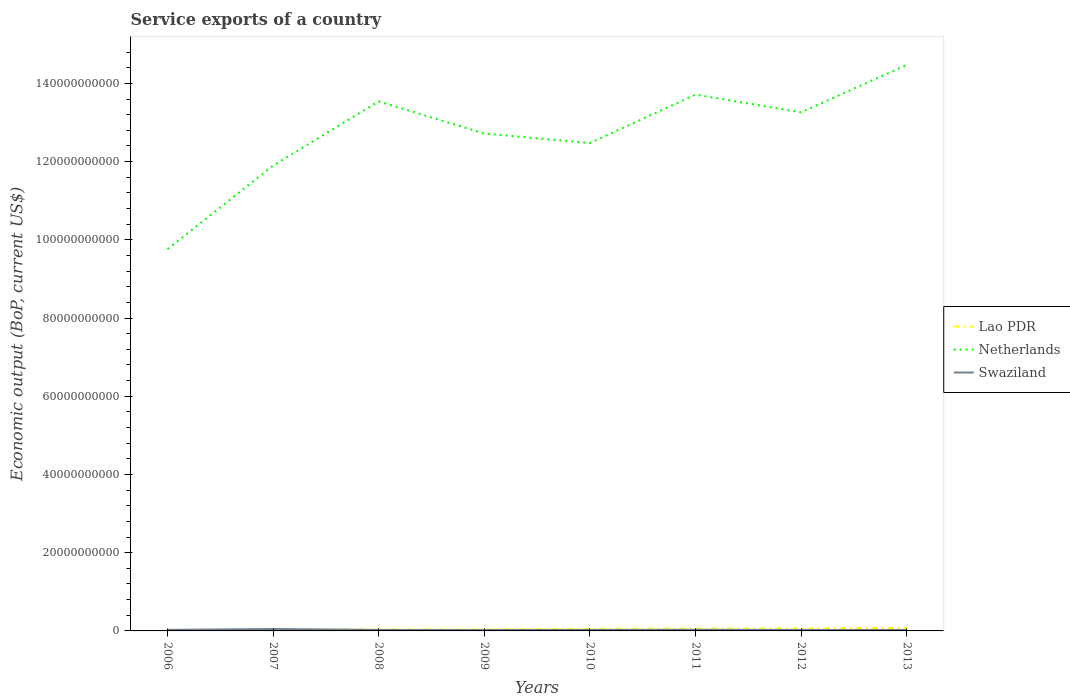How many different coloured lines are there?
Provide a succinct answer. 3. Does the line corresponding to Lao PDR intersect with the line corresponding to Swaziland?
Offer a terse response. Yes. Is the number of lines equal to the number of legend labels?
Offer a very short reply. Yes. Across all years, what is the maximum service exports in Netherlands?
Your answer should be compact. 9.76e+1. What is the total service exports in Lao PDR in the graph?
Provide a succinct answer. -1.80e+08. What is the difference between the highest and the second highest service exports in Swaziland?
Offer a very short reply. 2.83e+08. What is the difference between the highest and the lowest service exports in Netherlands?
Ensure brevity in your answer.  4. What is the difference between two consecutive major ticks on the Y-axis?
Provide a short and direct response. 2.00e+1. Does the graph contain any zero values?
Make the answer very short. No. Where does the legend appear in the graph?
Your answer should be very brief. Center right. How are the legend labels stacked?
Offer a very short reply. Vertical. What is the title of the graph?
Your response must be concise. Service exports of a country. What is the label or title of the Y-axis?
Keep it short and to the point. Economic output (BoP, current US$). What is the Economic output (BoP, current US$) of Lao PDR in 2006?
Offer a terse response. 2.23e+08. What is the Economic output (BoP, current US$) of Netherlands in 2006?
Offer a terse response. 9.76e+1. What is the Economic output (BoP, current US$) in Swaziland in 2006?
Give a very brief answer. 2.77e+08. What is the Economic output (BoP, current US$) of Lao PDR in 2007?
Provide a succinct answer. 2.78e+08. What is the Economic output (BoP, current US$) in Netherlands in 2007?
Keep it short and to the point. 1.19e+11. What is the Economic output (BoP, current US$) in Swaziland in 2007?
Your response must be concise. 4.93e+08. What is the Economic output (BoP, current US$) in Lao PDR in 2008?
Give a very brief answer. 4.02e+08. What is the Economic output (BoP, current US$) of Netherlands in 2008?
Your answer should be compact. 1.35e+11. What is the Economic output (BoP, current US$) of Swaziland in 2008?
Offer a terse response. 2.55e+08. What is the Economic output (BoP, current US$) of Lao PDR in 2009?
Your answer should be very brief. 3.97e+08. What is the Economic output (BoP, current US$) in Netherlands in 2009?
Provide a succinct answer. 1.27e+11. What is the Economic output (BoP, current US$) in Swaziland in 2009?
Keep it short and to the point. 2.11e+08. What is the Economic output (BoP, current US$) of Lao PDR in 2010?
Offer a very short reply. 5.11e+08. What is the Economic output (BoP, current US$) in Netherlands in 2010?
Keep it short and to the point. 1.25e+11. What is the Economic output (BoP, current US$) in Swaziland in 2010?
Ensure brevity in your answer.  2.58e+08. What is the Economic output (BoP, current US$) of Lao PDR in 2011?
Make the answer very short. 5.50e+08. What is the Economic output (BoP, current US$) of Netherlands in 2011?
Your answer should be very brief. 1.37e+11. What is the Economic output (BoP, current US$) in Swaziland in 2011?
Your response must be concise. 3.00e+08. What is the Economic output (BoP, current US$) of Lao PDR in 2012?
Keep it short and to the point. 5.77e+08. What is the Economic output (BoP, current US$) in Netherlands in 2012?
Ensure brevity in your answer.  1.33e+11. What is the Economic output (BoP, current US$) of Swaziland in 2012?
Ensure brevity in your answer.  2.42e+08. What is the Economic output (BoP, current US$) in Lao PDR in 2013?
Your response must be concise. 7.81e+08. What is the Economic output (BoP, current US$) of Netherlands in 2013?
Make the answer very short. 1.45e+11. What is the Economic output (BoP, current US$) of Swaziland in 2013?
Provide a succinct answer. 2.32e+08. Across all years, what is the maximum Economic output (BoP, current US$) in Lao PDR?
Your response must be concise. 7.81e+08. Across all years, what is the maximum Economic output (BoP, current US$) in Netherlands?
Your answer should be very brief. 1.45e+11. Across all years, what is the maximum Economic output (BoP, current US$) in Swaziland?
Offer a very short reply. 4.93e+08. Across all years, what is the minimum Economic output (BoP, current US$) in Lao PDR?
Your response must be concise. 2.23e+08. Across all years, what is the minimum Economic output (BoP, current US$) of Netherlands?
Keep it short and to the point. 9.76e+1. Across all years, what is the minimum Economic output (BoP, current US$) in Swaziland?
Make the answer very short. 2.11e+08. What is the total Economic output (BoP, current US$) of Lao PDR in the graph?
Ensure brevity in your answer.  3.72e+09. What is the total Economic output (BoP, current US$) of Netherlands in the graph?
Your response must be concise. 1.02e+12. What is the total Economic output (BoP, current US$) of Swaziland in the graph?
Your answer should be compact. 2.27e+09. What is the difference between the Economic output (BoP, current US$) in Lao PDR in 2006 and that in 2007?
Provide a short and direct response. -5.47e+07. What is the difference between the Economic output (BoP, current US$) of Netherlands in 2006 and that in 2007?
Keep it short and to the point. -2.14e+1. What is the difference between the Economic output (BoP, current US$) of Swaziland in 2006 and that in 2007?
Offer a terse response. -2.16e+08. What is the difference between the Economic output (BoP, current US$) of Lao PDR in 2006 and that in 2008?
Your answer should be very brief. -1.78e+08. What is the difference between the Economic output (BoP, current US$) in Netherlands in 2006 and that in 2008?
Your answer should be very brief. -3.78e+1. What is the difference between the Economic output (BoP, current US$) of Swaziland in 2006 and that in 2008?
Give a very brief answer. 2.22e+07. What is the difference between the Economic output (BoP, current US$) of Lao PDR in 2006 and that in 2009?
Provide a short and direct response. -1.74e+08. What is the difference between the Economic output (BoP, current US$) in Netherlands in 2006 and that in 2009?
Ensure brevity in your answer.  -2.96e+1. What is the difference between the Economic output (BoP, current US$) in Swaziland in 2006 and that in 2009?
Keep it short and to the point. 6.68e+07. What is the difference between the Economic output (BoP, current US$) in Lao PDR in 2006 and that in 2010?
Offer a terse response. -2.88e+08. What is the difference between the Economic output (BoP, current US$) in Netherlands in 2006 and that in 2010?
Provide a succinct answer. -2.71e+1. What is the difference between the Economic output (BoP, current US$) of Swaziland in 2006 and that in 2010?
Provide a succinct answer. 1.97e+07. What is the difference between the Economic output (BoP, current US$) in Lao PDR in 2006 and that in 2011?
Provide a succinct answer. -3.26e+08. What is the difference between the Economic output (BoP, current US$) in Netherlands in 2006 and that in 2011?
Offer a terse response. -3.95e+1. What is the difference between the Economic output (BoP, current US$) in Swaziland in 2006 and that in 2011?
Keep it short and to the point. -2.24e+07. What is the difference between the Economic output (BoP, current US$) in Lao PDR in 2006 and that in 2012?
Your answer should be very brief. -3.54e+08. What is the difference between the Economic output (BoP, current US$) of Netherlands in 2006 and that in 2012?
Provide a succinct answer. -3.50e+1. What is the difference between the Economic output (BoP, current US$) of Swaziland in 2006 and that in 2012?
Offer a terse response. 3.55e+07. What is the difference between the Economic output (BoP, current US$) in Lao PDR in 2006 and that in 2013?
Offer a very short reply. -5.58e+08. What is the difference between the Economic output (BoP, current US$) in Netherlands in 2006 and that in 2013?
Provide a succinct answer. -4.71e+1. What is the difference between the Economic output (BoP, current US$) in Swaziland in 2006 and that in 2013?
Offer a very short reply. 4.55e+07. What is the difference between the Economic output (BoP, current US$) in Lao PDR in 2007 and that in 2008?
Give a very brief answer. -1.23e+08. What is the difference between the Economic output (BoP, current US$) of Netherlands in 2007 and that in 2008?
Give a very brief answer. -1.64e+1. What is the difference between the Economic output (BoP, current US$) in Swaziland in 2007 and that in 2008?
Ensure brevity in your answer.  2.38e+08. What is the difference between the Economic output (BoP, current US$) of Lao PDR in 2007 and that in 2009?
Offer a very short reply. -1.19e+08. What is the difference between the Economic output (BoP, current US$) in Netherlands in 2007 and that in 2009?
Give a very brief answer. -8.19e+09. What is the difference between the Economic output (BoP, current US$) in Swaziland in 2007 and that in 2009?
Keep it short and to the point. 2.83e+08. What is the difference between the Economic output (BoP, current US$) of Lao PDR in 2007 and that in 2010?
Your answer should be very brief. -2.33e+08. What is the difference between the Economic output (BoP, current US$) of Netherlands in 2007 and that in 2010?
Your answer should be very brief. -5.76e+09. What is the difference between the Economic output (BoP, current US$) of Swaziland in 2007 and that in 2010?
Your response must be concise. 2.36e+08. What is the difference between the Economic output (BoP, current US$) in Lao PDR in 2007 and that in 2011?
Make the answer very short. -2.72e+08. What is the difference between the Economic output (BoP, current US$) in Netherlands in 2007 and that in 2011?
Your response must be concise. -1.81e+1. What is the difference between the Economic output (BoP, current US$) of Swaziland in 2007 and that in 2011?
Ensure brevity in your answer.  1.93e+08. What is the difference between the Economic output (BoP, current US$) of Lao PDR in 2007 and that in 2012?
Give a very brief answer. -2.99e+08. What is the difference between the Economic output (BoP, current US$) of Netherlands in 2007 and that in 2012?
Your answer should be compact. -1.36e+1. What is the difference between the Economic output (BoP, current US$) of Swaziland in 2007 and that in 2012?
Your answer should be very brief. 2.51e+08. What is the difference between the Economic output (BoP, current US$) of Lao PDR in 2007 and that in 2013?
Offer a terse response. -5.03e+08. What is the difference between the Economic output (BoP, current US$) of Netherlands in 2007 and that in 2013?
Make the answer very short. -2.58e+1. What is the difference between the Economic output (BoP, current US$) in Swaziland in 2007 and that in 2013?
Your answer should be compact. 2.61e+08. What is the difference between the Economic output (BoP, current US$) in Lao PDR in 2008 and that in 2009?
Make the answer very short. 4.36e+06. What is the difference between the Economic output (BoP, current US$) of Netherlands in 2008 and that in 2009?
Offer a very short reply. 8.22e+09. What is the difference between the Economic output (BoP, current US$) in Swaziland in 2008 and that in 2009?
Offer a terse response. 4.46e+07. What is the difference between the Economic output (BoP, current US$) in Lao PDR in 2008 and that in 2010?
Your answer should be very brief. -1.09e+08. What is the difference between the Economic output (BoP, current US$) in Netherlands in 2008 and that in 2010?
Provide a succinct answer. 1.07e+1. What is the difference between the Economic output (BoP, current US$) in Swaziland in 2008 and that in 2010?
Give a very brief answer. -2.44e+06. What is the difference between the Economic output (BoP, current US$) in Lao PDR in 2008 and that in 2011?
Ensure brevity in your answer.  -1.48e+08. What is the difference between the Economic output (BoP, current US$) of Netherlands in 2008 and that in 2011?
Keep it short and to the point. -1.73e+09. What is the difference between the Economic output (BoP, current US$) of Swaziland in 2008 and that in 2011?
Offer a very short reply. -4.46e+07. What is the difference between the Economic output (BoP, current US$) in Lao PDR in 2008 and that in 2012?
Offer a very short reply. -1.76e+08. What is the difference between the Economic output (BoP, current US$) of Netherlands in 2008 and that in 2012?
Your response must be concise. 2.80e+09. What is the difference between the Economic output (BoP, current US$) in Swaziland in 2008 and that in 2012?
Offer a terse response. 1.33e+07. What is the difference between the Economic output (BoP, current US$) of Lao PDR in 2008 and that in 2013?
Ensure brevity in your answer.  -3.80e+08. What is the difference between the Economic output (BoP, current US$) of Netherlands in 2008 and that in 2013?
Offer a very short reply. -9.34e+09. What is the difference between the Economic output (BoP, current US$) in Swaziland in 2008 and that in 2013?
Your answer should be compact. 2.33e+07. What is the difference between the Economic output (BoP, current US$) in Lao PDR in 2009 and that in 2010?
Provide a short and direct response. -1.14e+08. What is the difference between the Economic output (BoP, current US$) of Netherlands in 2009 and that in 2010?
Provide a succinct answer. 2.43e+09. What is the difference between the Economic output (BoP, current US$) of Swaziland in 2009 and that in 2010?
Offer a terse response. -4.70e+07. What is the difference between the Economic output (BoP, current US$) in Lao PDR in 2009 and that in 2011?
Keep it short and to the point. -1.52e+08. What is the difference between the Economic output (BoP, current US$) of Netherlands in 2009 and that in 2011?
Your answer should be compact. -9.95e+09. What is the difference between the Economic output (BoP, current US$) of Swaziland in 2009 and that in 2011?
Offer a very short reply. -8.92e+07. What is the difference between the Economic output (BoP, current US$) in Lao PDR in 2009 and that in 2012?
Your response must be concise. -1.80e+08. What is the difference between the Economic output (BoP, current US$) of Netherlands in 2009 and that in 2012?
Provide a succinct answer. -5.42e+09. What is the difference between the Economic output (BoP, current US$) of Swaziland in 2009 and that in 2012?
Provide a short and direct response. -3.13e+07. What is the difference between the Economic output (BoP, current US$) of Lao PDR in 2009 and that in 2013?
Ensure brevity in your answer.  -3.84e+08. What is the difference between the Economic output (BoP, current US$) of Netherlands in 2009 and that in 2013?
Your answer should be very brief. -1.76e+1. What is the difference between the Economic output (BoP, current US$) of Swaziland in 2009 and that in 2013?
Your answer should be very brief. -2.13e+07. What is the difference between the Economic output (BoP, current US$) of Lao PDR in 2010 and that in 2011?
Your answer should be compact. -3.86e+07. What is the difference between the Economic output (BoP, current US$) of Netherlands in 2010 and that in 2011?
Your answer should be compact. -1.24e+1. What is the difference between the Economic output (BoP, current US$) in Swaziland in 2010 and that in 2011?
Your answer should be compact. -4.22e+07. What is the difference between the Economic output (BoP, current US$) of Lao PDR in 2010 and that in 2012?
Offer a very short reply. -6.62e+07. What is the difference between the Economic output (BoP, current US$) in Netherlands in 2010 and that in 2012?
Your answer should be compact. -7.86e+09. What is the difference between the Economic output (BoP, current US$) of Swaziland in 2010 and that in 2012?
Offer a terse response. 1.57e+07. What is the difference between the Economic output (BoP, current US$) in Lao PDR in 2010 and that in 2013?
Keep it short and to the point. -2.70e+08. What is the difference between the Economic output (BoP, current US$) in Netherlands in 2010 and that in 2013?
Give a very brief answer. -2.00e+1. What is the difference between the Economic output (BoP, current US$) of Swaziland in 2010 and that in 2013?
Provide a short and direct response. 2.57e+07. What is the difference between the Economic output (BoP, current US$) of Lao PDR in 2011 and that in 2012?
Ensure brevity in your answer.  -2.76e+07. What is the difference between the Economic output (BoP, current US$) of Netherlands in 2011 and that in 2012?
Provide a short and direct response. 4.52e+09. What is the difference between the Economic output (BoP, current US$) of Swaziland in 2011 and that in 2012?
Offer a terse response. 5.79e+07. What is the difference between the Economic output (BoP, current US$) of Lao PDR in 2011 and that in 2013?
Ensure brevity in your answer.  -2.32e+08. What is the difference between the Economic output (BoP, current US$) in Netherlands in 2011 and that in 2013?
Make the answer very short. -7.62e+09. What is the difference between the Economic output (BoP, current US$) of Swaziland in 2011 and that in 2013?
Keep it short and to the point. 6.79e+07. What is the difference between the Economic output (BoP, current US$) of Lao PDR in 2012 and that in 2013?
Provide a short and direct response. -2.04e+08. What is the difference between the Economic output (BoP, current US$) in Netherlands in 2012 and that in 2013?
Provide a succinct answer. -1.21e+1. What is the difference between the Economic output (BoP, current US$) in Swaziland in 2012 and that in 2013?
Offer a very short reply. 1.00e+07. What is the difference between the Economic output (BoP, current US$) in Lao PDR in 2006 and the Economic output (BoP, current US$) in Netherlands in 2007?
Your answer should be compact. -1.19e+11. What is the difference between the Economic output (BoP, current US$) of Lao PDR in 2006 and the Economic output (BoP, current US$) of Swaziland in 2007?
Offer a terse response. -2.70e+08. What is the difference between the Economic output (BoP, current US$) of Netherlands in 2006 and the Economic output (BoP, current US$) of Swaziland in 2007?
Make the answer very short. 9.71e+1. What is the difference between the Economic output (BoP, current US$) in Lao PDR in 2006 and the Economic output (BoP, current US$) in Netherlands in 2008?
Ensure brevity in your answer.  -1.35e+11. What is the difference between the Economic output (BoP, current US$) in Lao PDR in 2006 and the Economic output (BoP, current US$) in Swaziland in 2008?
Make the answer very short. -3.17e+07. What is the difference between the Economic output (BoP, current US$) in Netherlands in 2006 and the Economic output (BoP, current US$) in Swaziland in 2008?
Keep it short and to the point. 9.74e+1. What is the difference between the Economic output (BoP, current US$) of Lao PDR in 2006 and the Economic output (BoP, current US$) of Netherlands in 2009?
Offer a very short reply. -1.27e+11. What is the difference between the Economic output (BoP, current US$) in Lao PDR in 2006 and the Economic output (BoP, current US$) in Swaziland in 2009?
Offer a very short reply. 1.29e+07. What is the difference between the Economic output (BoP, current US$) in Netherlands in 2006 and the Economic output (BoP, current US$) in Swaziland in 2009?
Ensure brevity in your answer.  9.74e+1. What is the difference between the Economic output (BoP, current US$) in Lao PDR in 2006 and the Economic output (BoP, current US$) in Netherlands in 2010?
Your answer should be compact. -1.25e+11. What is the difference between the Economic output (BoP, current US$) in Lao PDR in 2006 and the Economic output (BoP, current US$) in Swaziland in 2010?
Give a very brief answer. -3.41e+07. What is the difference between the Economic output (BoP, current US$) in Netherlands in 2006 and the Economic output (BoP, current US$) in Swaziland in 2010?
Your answer should be compact. 9.74e+1. What is the difference between the Economic output (BoP, current US$) in Lao PDR in 2006 and the Economic output (BoP, current US$) in Netherlands in 2011?
Your response must be concise. -1.37e+11. What is the difference between the Economic output (BoP, current US$) of Lao PDR in 2006 and the Economic output (BoP, current US$) of Swaziland in 2011?
Provide a short and direct response. -7.63e+07. What is the difference between the Economic output (BoP, current US$) in Netherlands in 2006 and the Economic output (BoP, current US$) in Swaziland in 2011?
Provide a succinct answer. 9.73e+1. What is the difference between the Economic output (BoP, current US$) of Lao PDR in 2006 and the Economic output (BoP, current US$) of Netherlands in 2012?
Ensure brevity in your answer.  -1.32e+11. What is the difference between the Economic output (BoP, current US$) in Lao PDR in 2006 and the Economic output (BoP, current US$) in Swaziland in 2012?
Provide a succinct answer. -1.84e+07. What is the difference between the Economic output (BoP, current US$) in Netherlands in 2006 and the Economic output (BoP, current US$) in Swaziland in 2012?
Your answer should be compact. 9.74e+1. What is the difference between the Economic output (BoP, current US$) of Lao PDR in 2006 and the Economic output (BoP, current US$) of Netherlands in 2013?
Ensure brevity in your answer.  -1.45e+11. What is the difference between the Economic output (BoP, current US$) of Lao PDR in 2006 and the Economic output (BoP, current US$) of Swaziland in 2013?
Keep it short and to the point. -8.38e+06. What is the difference between the Economic output (BoP, current US$) of Netherlands in 2006 and the Economic output (BoP, current US$) of Swaziland in 2013?
Offer a terse response. 9.74e+1. What is the difference between the Economic output (BoP, current US$) of Lao PDR in 2007 and the Economic output (BoP, current US$) of Netherlands in 2008?
Your answer should be very brief. -1.35e+11. What is the difference between the Economic output (BoP, current US$) of Lao PDR in 2007 and the Economic output (BoP, current US$) of Swaziland in 2008?
Your answer should be very brief. 2.30e+07. What is the difference between the Economic output (BoP, current US$) in Netherlands in 2007 and the Economic output (BoP, current US$) in Swaziland in 2008?
Your answer should be compact. 1.19e+11. What is the difference between the Economic output (BoP, current US$) in Lao PDR in 2007 and the Economic output (BoP, current US$) in Netherlands in 2009?
Your response must be concise. -1.27e+11. What is the difference between the Economic output (BoP, current US$) of Lao PDR in 2007 and the Economic output (BoP, current US$) of Swaziland in 2009?
Offer a very short reply. 6.76e+07. What is the difference between the Economic output (BoP, current US$) of Netherlands in 2007 and the Economic output (BoP, current US$) of Swaziland in 2009?
Your answer should be compact. 1.19e+11. What is the difference between the Economic output (BoP, current US$) of Lao PDR in 2007 and the Economic output (BoP, current US$) of Netherlands in 2010?
Provide a short and direct response. -1.24e+11. What is the difference between the Economic output (BoP, current US$) of Lao PDR in 2007 and the Economic output (BoP, current US$) of Swaziland in 2010?
Offer a terse response. 2.06e+07. What is the difference between the Economic output (BoP, current US$) of Netherlands in 2007 and the Economic output (BoP, current US$) of Swaziland in 2010?
Ensure brevity in your answer.  1.19e+11. What is the difference between the Economic output (BoP, current US$) of Lao PDR in 2007 and the Economic output (BoP, current US$) of Netherlands in 2011?
Your answer should be compact. -1.37e+11. What is the difference between the Economic output (BoP, current US$) of Lao PDR in 2007 and the Economic output (BoP, current US$) of Swaziland in 2011?
Provide a succinct answer. -2.16e+07. What is the difference between the Economic output (BoP, current US$) in Netherlands in 2007 and the Economic output (BoP, current US$) in Swaziland in 2011?
Your answer should be very brief. 1.19e+11. What is the difference between the Economic output (BoP, current US$) of Lao PDR in 2007 and the Economic output (BoP, current US$) of Netherlands in 2012?
Make the answer very short. -1.32e+11. What is the difference between the Economic output (BoP, current US$) in Lao PDR in 2007 and the Economic output (BoP, current US$) in Swaziland in 2012?
Offer a very short reply. 3.63e+07. What is the difference between the Economic output (BoP, current US$) of Netherlands in 2007 and the Economic output (BoP, current US$) of Swaziland in 2012?
Ensure brevity in your answer.  1.19e+11. What is the difference between the Economic output (BoP, current US$) in Lao PDR in 2007 and the Economic output (BoP, current US$) in Netherlands in 2013?
Offer a very short reply. -1.44e+11. What is the difference between the Economic output (BoP, current US$) of Lao PDR in 2007 and the Economic output (BoP, current US$) of Swaziland in 2013?
Keep it short and to the point. 4.63e+07. What is the difference between the Economic output (BoP, current US$) in Netherlands in 2007 and the Economic output (BoP, current US$) in Swaziland in 2013?
Make the answer very short. 1.19e+11. What is the difference between the Economic output (BoP, current US$) of Lao PDR in 2008 and the Economic output (BoP, current US$) of Netherlands in 2009?
Your answer should be compact. -1.27e+11. What is the difference between the Economic output (BoP, current US$) of Lao PDR in 2008 and the Economic output (BoP, current US$) of Swaziland in 2009?
Your response must be concise. 1.91e+08. What is the difference between the Economic output (BoP, current US$) of Netherlands in 2008 and the Economic output (BoP, current US$) of Swaziland in 2009?
Ensure brevity in your answer.  1.35e+11. What is the difference between the Economic output (BoP, current US$) in Lao PDR in 2008 and the Economic output (BoP, current US$) in Netherlands in 2010?
Give a very brief answer. -1.24e+11. What is the difference between the Economic output (BoP, current US$) in Lao PDR in 2008 and the Economic output (BoP, current US$) in Swaziland in 2010?
Offer a very short reply. 1.44e+08. What is the difference between the Economic output (BoP, current US$) of Netherlands in 2008 and the Economic output (BoP, current US$) of Swaziland in 2010?
Ensure brevity in your answer.  1.35e+11. What is the difference between the Economic output (BoP, current US$) of Lao PDR in 2008 and the Economic output (BoP, current US$) of Netherlands in 2011?
Your response must be concise. -1.37e+11. What is the difference between the Economic output (BoP, current US$) of Lao PDR in 2008 and the Economic output (BoP, current US$) of Swaziland in 2011?
Provide a succinct answer. 1.02e+08. What is the difference between the Economic output (BoP, current US$) of Netherlands in 2008 and the Economic output (BoP, current US$) of Swaziland in 2011?
Give a very brief answer. 1.35e+11. What is the difference between the Economic output (BoP, current US$) of Lao PDR in 2008 and the Economic output (BoP, current US$) of Netherlands in 2012?
Offer a terse response. -1.32e+11. What is the difference between the Economic output (BoP, current US$) in Lao PDR in 2008 and the Economic output (BoP, current US$) in Swaziland in 2012?
Keep it short and to the point. 1.60e+08. What is the difference between the Economic output (BoP, current US$) of Netherlands in 2008 and the Economic output (BoP, current US$) of Swaziland in 2012?
Offer a very short reply. 1.35e+11. What is the difference between the Economic output (BoP, current US$) of Lao PDR in 2008 and the Economic output (BoP, current US$) of Netherlands in 2013?
Ensure brevity in your answer.  -1.44e+11. What is the difference between the Economic output (BoP, current US$) in Lao PDR in 2008 and the Economic output (BoP, current US$) in Swaziland in 2013?
Offer a terse response. 1.70e+08. What is the difference between the Economic output (BoP, current US$) of Netherlands in 2008 and the Economic output (BoP, current US$) of Swaziland in 2013?
Make the answer very short. 1.35e+11. What is the difference between the Economic output (BoP, current US$) in Lao PDR in 2009 and the Economic output (BoP, current US$) in Netherlands in 2010?
Offer a terse response. -1.24e+11. What is the difference between the Economic output (BoP, current US$) of Lao PDR in 2009 and the Economic output (BoP, current US$) of Swaziland in 2010?
Your answer should be very brief. 1.40e+08. What is the difference between the Economic output (BoP, current US$) in Netherlands in 2009 and the Economic output (BoP, current US$) in Swaziland in 2010?
Your answer should be compact. 1.27e+11. What is the difference between the Economic output (BoP, current US$) in Lao PDR in 2009 and the Economic output (BoP, current US$) in Netherlands in 2011?
Your response must be concise. -1.37e+11. What is the difference between the Economic output (BoP, current US$) of Lao PDR in 2009 and the Economic output (BoP, current US$) of Swaziland in 2011?
Offer a terse response. 9.76e+07. What is the difference between the Economic output (BoP, current US$) of Netherlands in 2009 and the Economic output (BoP, current US$) of Swaziland in 2011?
Offer a very short reply. 1.27e+11. What is the difference between the Economic output (BoP, current US$) of Lao PDR in 2009 and the Economic output (BoP, current US$) of Netherlands in 2012?
Offer a terse response. -1.32e+11. What is the difference between the Economic output (BoP, current US$) of Lao PDR in 2009 and the Economic output (BoP, current US$) of Swaziland in 2012?
Keep it short and to the point. 1.55e+08. What is the difference between the Economic output (BoP, current US$) of Netherlands in 2009 and the Economic output (BoP, current US$) of Swaziland in 2012?
Ensure brevity in your answer.  1.27e+11. What is the difference between the Economic output (BoP, current US$) in Lao PDR in 2009 and the Economic output (BoP, current US$) in Netherlands in 2013?
Provide a succinct answer. -1.44e+11. What is the difference between the Economic output (BoP, current US$) in Lao PDR in 2009 and the Economic output (BoP, current US$) in Swaziland in 2013?
Ensure brevity in your answer.  1.65e+08. What is the difference between the Economic output (BoP, current US$) in Netherlands in 2009 and the Economic output (BoP, current US$) in Swaziland in 2013?
Provide a short and direct response. 1.27e+11. What is the difference between the Economic output (BoP, current US$) of Lao PDR in 2010 and the Economic output (BoP, current US$) of Netherlands in 2011?
Your answer should be very brief. -1.37e+11. What is the difference between the Economic output (BoP, current US$) in Lao PDR in 2010 and the Economic output (BoP, current US$) in Swaziland in 2011?
Your answer should be compact. 2.11e+08. What is the difference between the Economic output (BoP, current US$) in Netherlands in 2010 and the Economic output (BoP, current US$) in Swaziland in 2011?
Keep it short and to the point. 1.24e+11. What is the difference between the Economic output (BoP, current US$) of Lao PDR in 2010 and the Economic output (BoP, current US$) of Netherlands in 2012?
Give a very brief answer. -1.32e+11. What is the difference between the Economic output (BoP, current US$) in Lao PDR in 2010 and the Economic output (BoP, current US$) in Swaziland in 2012?
Provide a succinct answer. 2.69e+08. What is the difference between the Economic output (BoP, current US$) of Netherlands in 2010 and the Economic output (BoP, current US$) of Swaziland in 2012?
Offer a very short reply. 1.25e+11. What is the difference between the Economic output (BoP, current US$) in Lao PDR in 2010 and the Economic output (BoP, current US$) in Netherlands in 2013?
Make the answer very short. -1.44e+11. What is the difference between the Economic output (BoP, current US$) in Lao PDR in 2010 and the Economic output (BoP, current US$) in Swaziland in 2013?
Your answer should be compact. 2.79e+08. What is the difference between the Economic output (BoP, current US$) of Netherlands in 2010 and the Economic output (BoP, current US$) of Swaziland in 2013?
Make the answer very short. 1.25e+11. What is the difference between the Economic output (BoP, current US$) of Lao PDR in 2011 and the Economic output (BoP, current US$) of Netherlands in 2012?
Provide a short and direct response. -1.32e+11. What is the difference between the Economic output (BoP, current US$) in Lao PDR in 2011 and the Economic output (BoP, current US$) in Swaziland in 2012?
Give a very brief answer. 3.08e+08. What is the difference between the Economic output (BoP, current US$) of Netherlands in 2011 and the Economic output (BoP, current US$) of Swaziland in 2012?
Give a very brief answer. 1.37e+11. What is the difference between the Economic output (BoP, current US$) in Lao PDR in 2011 and the Economic output (BoP, current US$) in Netherlands in 2013?
Ensure brevity in your answer.  -1.44e+11. What is the difference between the Economic output (BoP, current US$) of Lao PDR in 2011 and the Economic output (BoP, current US$) of Swaziland in 2013?
Give a very brief answer. 3.18e+08. What is the difference between the Economic output (BoP, current US$) of Netherlands in 2011 and the Economic output (BoP, current US$) of Swaziland in 2013?
Give a very brief answer. 1.37e+11. What is the difference between the Economic output (BoP, current US$) in Lao PDR in 2012 and the Economic output (BoP, current US$) in Netherlands in 2013?
Your answer should be compact. -1.44e+11. What is the difference between the Economic output (BoP, current US$) in Lao PDR in 2012 and the Economic output (BoP, current US$) in Swaziland in 2013?
Your answer should be very brief. 3.45e+08. What is the difference between the Economic output (BoP, current US$) in Netherlands in 2012 and the Economic output (BoP, current US$) in Swaziland in 2013?
Provide a short and direct response. 1.32e+11. What is the average Economic output (BoP, current US$) in Lao PDR per year?
Your answer should be compact. 4.65e+08. What is the average Economic output (BoP, current US$) of Netherlands per year?
Keep it short and to the point. 1.27e+11. What is the average Economic output (BoP, current US$) of Swaziland per year?
Give a very brief answer. 2.83e+08. In the year 2006, what is the difference between the Economic output (BoP, current US$) in Lao PDR and Economic output (BoP, current US$) in Netherlands?
Give a very brief answer. -9.74e+1. In the year 2006, what is the difference between the Economic output (BoP, current US$) of Lao PDR and Economic output (BoP, current US$) of Swaziland?
Keep it short and to the point. -5.38e+07. In the year 2006, what is the difference between the Economic output (BoP, current US$) of Netherlands and Economic output (BoP, current US$) of Swaziland?
Your response must be concise. 9.73e+1. In the year 2007, what is the difference between the Economic output (BoP, current US$) of Lao PDR and Economic output (BoP, current US$) of Netherlands?
Keep it short and to the point. -1.19e+11. In the year 2007, what is the difference between the Economic output (BoP, current US$) of Lao PDR and Economic output (BoP, current US$) of Swaziland?
Your answer should be very brief. -2.15e+08. In the year 2007, what is the difference between the Economic output (BoP, current US$) in Netherlands and Economic output (BoP, current US$) in Swaziland?
Provide a succinct answer. 1.18e+11. In the year 2008, what is the difference between the Economic output (BoP, current US$) in Lao PDR and Economic output (BoP, current US$) in Netherlands?
Keep it short and to the point. -1.35e+11. In the year 2008, what is the difference between the Economic output (BoP, current US$) of Lao PDR and Economic output (BoP, current US$) of Swaziland?
Your response must be concise. 1.47e+08. In the year 2008, what is the difference between the Economic output (BoP, current US$) in Netherlands and Economic output (BoP, current US$) in Swaziland?
Ensure brevity in your answer.  1.35e+11. In the year 2009, what is the difference between the Economic output (BoP, current US$) of Lao PDR and Economic output (BoP, current US$) of Netherlands?
Your answer should be very brief. -1.27e+11. In the year 2009, what is the difference between the Economic output (BoP, current US$) in Lao PDR and Economic output (BoP, current US$) in Swaziland?
Your answer should be very brief. 1.87e+08. In the year 2009, what is the difference between the Economic output (BoP, current US$) in Netherlands and Economic output (BoP, current US$) in Swaziland?
Ensure brevity in your answer.  1.27e+11. In the year 2010, what is the difference between the Economic output (BoP, current US$) of Lao PDR and Economic output (BoP, current US$) of Netherlands?
Give a very brief answer. -1.24e+11. In the year 2010, what is the difference between the Economic output (BoP, current US$) in Lao PDR and Economic output (BoP, current US$) in Swaziland?
Your answer should be compact. 2.53e+08. In the year 2010, what is the difference between the Economic output (BoP, current US$) of Netherlands and Economic output (BoP, current US$) of Swaziland?
Your response must be concise. 1.24e+11. In the year 2011, what is the difference between the Economic output (BoP, current US$) in Lao PDR and Economic output (BoP, current US$) in Netherlands?
Offer a very short reply. -1.37e+11. In the year 2011, what is the difference between the Economic output (BoP, current US$) in Lao PDR and Economic output (BoP, current US$) in Swaziland?
Provide a succinct answer. 2.50e+08. In the year 2011, what is the difference between the Economic output (BoP, current US$) in Netherlands and Economic output (BoP, current US$) in Swaziland?
Your answer should be compact. 1.37e+11. In the year 2012, what is the difference between the Economic output (BoP, current US$) of Lao PDR and Economic output (BoP, current US$) of Netherlands?
Your response must be concise. -1.32e+11. In the year 2012, what is the difference between the Economic output (BoP, current US$) in Lao PDR and Economic output (BoP, current US$) in Swaziland?
Your response must be concise. 3.35e+08. In the year 2012, what is the difference between the Economic output (BoP, current US$) in Netherlands and Economic output (BoP, current US$) in Swaziland?
Your answer should be very brief. 1.32e+11. In the year 2013, what is the difference between the Economic output (BoP, current US$) of Lao PDR and Economic output (BoP, current US$) of Netherlands?
Keep it short and to the point. -1.44e+11. In the year 2013, what is the difference between the Economic output (BoP, current US$) of Lao PDR and Economic output (BoP, current US$) of Swaziland?
Give a very brief answer. 5.49e+08. In the year 2013, what is the difference between the Economic output (BoP, current US$) in Netherlands and Economic output (BoP, current US$) in Swaziland?
Ensure brevity in your answer.  1.45e+11. What is the ratio of the Economic output (BoP, current US$) of Lao PDR in 2006 to that in 2007?
Provide a succinct answer. 0.8. What is the ratio of the Economic output (BoP, current US$) in Netherlands in 2006 to that in 2007?
Your response must be concise. 0.82. What is the ratio of the Economic output (BoP, current US$) of Swaziland in 2006 to that in 2007?
Your answer should be compact. 0.56. What is the ratio of the Economic output (BoP, current US$) in Lao PDR in 2006 to that in 2008?
Provide a succinct answer. 0.56. What is the ratio of the Economic output (BoP, current US$) in Netherlands in 2006 to that in 2008?
Give a very brief answer. 0.72. What is the ratio of the Economic output (BoP, current US$) in Swaziland in 2006 to that in 2008?
Offer a very short reply. 1.09. What is the ratio of the Economic output (BoP, current US$) of Lao PDR in 2006 to that in 2009?
Your response must be concise. 0.56. What is the ratio of the Economic output (BoP, current US$) of Netherlands in 2006 to that in 2009?
Provide a short and direct response. 0.77. What is the ratio of the Economic output (BoP, current US$) in Swaziland in 2006 to that in 2009?
Offer a very short reply. 1.32. What is the ratio of the Economic output (BoP, current US$) of Lao PDR in 2006 to that in 2010?
Your answer should be compact. 0.44. What is the ratio of the Economic output (BoP, current US$) in Netherlands in 2006 to that in 2010?
Give a very brief answer. 0.78. What is the ratio of the Economic output (BoP, current US$) in Swaziland in 2006 to that in 2010?
Ensure brevity in your answer.  1.08. What is the ratio of the Economic output (BoP, current US$) in Lao PDR in 2006 to that in 2011?
Offer a terse response. 0.41. What is the ratio of the Economic output (BoP, current US$) in Netherlands in 2006 to that in 2011?
Provide a short and direct response. 0.71. What is the ratio of the Economic output (BoP, current US$) of Swaziland in 2006 to that in 2011?
Give a very brief answer. 0.93. What is the ratio of the Economic output (BoP, current US$) in Lao PDR in 2006 to that in 2012?
Provide a short and direct response. 0.39. What is the ratio of the Economic output (BoP, current US$) of Netherlands in 2006 to that in 2012?
Make the answer very short. 0.74. What is the ratio of the Economic output (BoP, current US$) of Swaziland in 2006 to that in 2012?
Offer a terse response. 1.15. What is the ratio of the Economic output (BoP, current US$) in Lao PDR in 2006 to that in 2013?
Your answer should be compact. 0.29. What is the ratio of the Economic output (BoP, current US$) in Netherlands in 2006 to that in 2013?
Your answer should be very brief. 0.67. What is the ratio of the Economic output (BoP, current US$) in Swaziland in 2006 to that in 2013?
Provide a short and direct response. 1.2. What is the ratio of the Economic output (BoP, current US$) in Lao PDR in 2007 to that in 2008?
Offer a very short reply. 0.69. What is the ratio of the Economic output (BoP, current US$) of Netherlands in 2007 to that in 2008?
Keep it short and to the point. 0.88. What is the ratio of the Economic output (BoP, current US$) of Swaziland in 2007 to that in 2008?
Provide a succinct answer. 1.93. What is the ratio of the Economic output (BoP, current US$) in Lao PDR in 2007 to that in 2009?
Your answer should be compact. 0.7. What is the ratio of the Economic output (BoP, current US$) of Netherlands in 2007 to that in 2009?
Offer a terse response. 0.94. What is the ratio of the Economic output (BoP, current US$) of Swaziland in 2007 to that in 2009?
Provide a succinct answer. 2.34. What is the ratio of the Economic output (BoP, current US$) in Lao PDR in 2007 to that in 2010?
Make the answer very short. 0.54. What is the ratio of the Economic output (BoP, current US$) in Netherlands in 2007 to that in 2010?
Keep it short and to the point. 0.95. What is the ratio of the Economic output (BoP, current US$) in Swaziland in 2007 to that in 2010?
Provide a short and direct response. 1.91. What is the ratio of the Economic output (BoP, current US$) in Lao PDR in 2007 to that in 2011?
Offer a very short reply. 0.51. What is the ratio of the Economic output (BoP, current US$) of Netherlands in 2007 to that in 2011?
Offer a very short reply. 0.87. What is the ratio of the Economic output (BoP, current US$) in Swaziland in 2007 to that in 2011?
Offer a very short reply. 1.65. What is the ratio of the Economic output (BoP, current US$) of Lao PDR in 2007 to that in 2012?
Provide a succinct answer. 0.48. What is the ratio of the Economic output (BoP, current US$) in Netherlands in 2007 to that in 2012?
Provide a succinct answer. 0.9. What is the ratio of the Economic output (BoP, current US$) in Swaziland in 2007 to that in 2012?
Provide a succinct answer. 2.04. What is the ratio of the Economic output (BoP, current US$) in Lao PDR in 2007 to that in 2013?
Offer a terse response. 0.36. What is the ratio of the Economic output (BoP, current US$) of Netherlands in 2007 to that in 2013?
Offer a very short reply. 0.82. What is the ratio of the Economic output (BoP, current US$) of Swaziland in 2007 to that in 2013?
Keep it short and to the point. 2.13. What is the ratio of the Economic output (BoP, current US$) in Lao PDR in 2008 to that in 2009?
Give a very brief answer. 1.01. What is the ratio of the Economic output (BoP, current US$) of Netherlands in 2008 to that in 2009?
Give a very brief answer. 1.06. What is the ratio of the Economic output (BoP, current US$) of Swaziland in 2008 to that in 2009?
Give a very brief answer. 1.21. What is the ratio of the Economic output (BoP, current US$) of Lao PDR in 2008 to that in 2010?
Make the answer very short. 0.79. What is the ratio of the Economic output (BoP, current US$) in Netherlands in 2008 to that in 2010?
Your answer should be compact. 1.09. What is the ratio of the Economic output (BoP, current US$) of Swaziland in 2008 to that in 2010?
Offer a very short reply. 0.99. What is the ratio of the Economic output (BoP, current US$) in Lao PDR in 2008 to that in 2011?
Your answer should be very brief. 0.73. What is the ratio of the Economic output (BoP, current US$) in Netherlands in 2008 to that in 2011?
Offer a very short reply. 0.99. What is the ratio of the Economic output (BoP, current US$) of Swaziland in 2008 to that in 2011?
Provide a short and direct response. 0.85. What is the ratio of the Economic output (BoP, current US$) in Lao PDR in 2008 to that in 2012?
Your answer should be compact. 0.7. What is the ratio of the Economic output (BoP, current US$) in Netherlands in 2008 to that in 2012?
Ensure brevity in your answer.  1.02. What is the ratio of the Economic output (BoP, current US$) in Swaziland in 2008 to that in 2012?
Provide a short and direct response. 1.05. What is the ratio of the Economic output (BoP, current US$) in Lao PDR in 2008 to that in 2013?
Offer a very short reply. 0.51. What is the ratio of the Economic output (BoP, current US$) of Netherlands in 2008 to that in 2013?
Offer a very short reply. 0.94. What is the ratio of the Economic output (BoP, current US$) in Swaziland in 2008 to that in 2013?
Offer a very short reply. 1.1. What is the ratio of the Economic output (BoP, current US$) of Lao PDR in 2009 to that in 2010?
Provide a succinct answer. 0.78. What is the ratio of the Economic output (BoP, current US$) of Netherlands in 2009 to that in 2010?
Offer a terse response. 1.02. What is the ratio of the Economic output (BoP, current US$) of Swaziland in 2009 to that in 2010?
Your answer should be compact. 0.82. What is the ratio of the Economic output (BoP, current US$) in Lao PDR in 2009 to that in 2011?
Your answer should be compact. 0.72. What is the ratio of the Economic output (BoP, current US$) in Netherlands in 2009 to that in 2011?
Provide a short and direct response. 0.93. What is the ratio of the Economic output (BoP, current US$) of Swaziland in 2009 to that in 2011?
Offer a very short reply. 0.7. What is the ratio of the Economic output (BoP, current US$) of Lao PDR in 2009 to that in 2012?
Ensure brevity in your answer.  0.69. What is the ratio of the Economic output (BoP, current US$) of Netherlands in 2009 to that in 2012?
Offer a very short reply. 0.96. What is the ratio of the Economic output (BoP, current US$) in Swaziland in 2009 to that in 2012?
Offer a terse response. 0.87. What is the ratio of the Economic output (BoP, current US$) of Lao PDR in 2009 to that in 2013?
Your response must be concise. 0.51. What is the ratio of the Economic output (BoP, current US$) of Netherlands in 2009 to that in 2013?
Provide a short and direct response. 0.88. What is the ratio of the Economic output (BoP, current US$) of Swaziland in 2009 to that in 2013?
Your answer should be compact. 0.91. What is the ratio of the Economic output (BoP, current US$) in Lao PDR in 2010 to that in 2011?
Your answer should be very brief. 0.93. What is the ratio of the Economic output (BoP, current US$) in Netherlands in 2010 to that in 2011?
Your answer should be very brief. 0.91. What is the ratio of the Economic output (BoP, current US$) in Swaziland in 2010 to that in 2011?
Your response must be concise. 0.86. What is the ratio of the Economic output (BoP, current US$) in Lao PDR in 2010 to that in 2012?
Provide a short and direct response. 0.89. What is the ratio of the Economic output (BoP, current US$) of Netherlands in 2010 to that in 2012?
Ensure brevity in your answer.  0.94. What is the ratio of the Economic output (BoP, current US$) of Swaziland in 2010 to that in 2012?
Make the answer very short. 1.06. What is the ratio of the Economic output (BoP, current US$) in Lao PDR in 2010 to that in 2013?
Give a very brief answer. 0.65. What is the ratio of the Economic output (BoP, current US$) of Netherlands in 2010 to that in 2013?
Make the answer very short. 0.86. What is the ratio of the Economic output (BoP, current US$) in Swaziland in 2010 to that in 2013?
Offer a terse response. 1.11. What is the ratio of the Economic output (BoP, current US$) in Lao PDR in 2011 to that in 2012?
Your response must be concise. 0.95. What is the ratio of the Economic output (BoP, current US$) of Netherlands in 2011 to that in 2012?
Ensure brevity in your answer.  1.03. What is the ratio of the Economic output (BoP, current US$) in Swaziland in 2011 to that in 2012?
Offer a very short reply. 1.24. What is the ratio of the Economic output (BoP, current US$) in Lao PDR in 2011 to that in 2013?
Provide a short and direct response. 0.7. What is the ratio of the Economic output (BoP, current US$) of Netherlands in 2011 to that in 2013?
Provide a short and direct response. 0.95. What is the ratio of the Economic output (BoP, current US$) in Swaziland in 2011 to that in 2013?
Your response must be concise. 1.29. What is the ratio of the Economic output (BoP, current US$) of Lao PDR in 2012 to that in 2013?
Keep it short and to the point. 0.74. What is the ratio of the Economic output (BoP, current US$) of Netherlands in 2012 to that in 2013?
Provide a short and direct response. 0.92. What is the ratio of the Economic output (BoP, current US$) of Swaziland in 2012 to that in 2013?
Make the answer very short. 1.04. What is the difference between the highest and the second highest Economic output (BoP, current US$) of Lao PDR?
Your answer should be compact. 2.04e+08. What is the difference between the highest and the second highest Economic output (BoP, current US$) of Netherlands?
Offer a terse response. 7.62e+09. What is the difference between the highest and the second highest Economic output (BoP, current US$) of Swaziland?
Offer a very short reply. 1.93e+08. What is the difference between the highest and the lowest Economic output (BoP, current US$) in Lao PDR?
Ensure brevity in your answer.  5.58e+08. What is the difference between the highest and the lowest Economic output (BoP, current US$) of Netherlands?
Give a very brief answer. 4.71e+1. What is the difference between the highest and the lowest Economic output (BoP, current US$) of Swaziland?
Offer a terse response. 2.83e+08. 